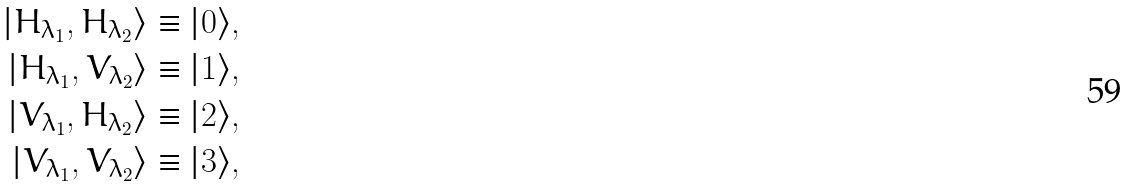Convert formula to latex. <formula><loc_0><loc_0><loc_500><loc_500>| H _ { \lambda _ { 1 } } , H _ { \lambda _ { 2 } } \rangle & \equiv | 0 \rangle , \\ | H _ { \lambda _ { 1 } } , V _ { \lambda _ { 2 } } \rangle & \equiv | 1 \rangle , \\ | V _ { \lambda _ { 1 } } , H _ { \lambda _ { 2 } } \rangle & \equiv | 2 \rangle , \\ | V _ { \lambda _ { 1 } } , V _ { \lambda _ { 2 } } \rangle & \equiv | 3 \rangle ,</formula> 